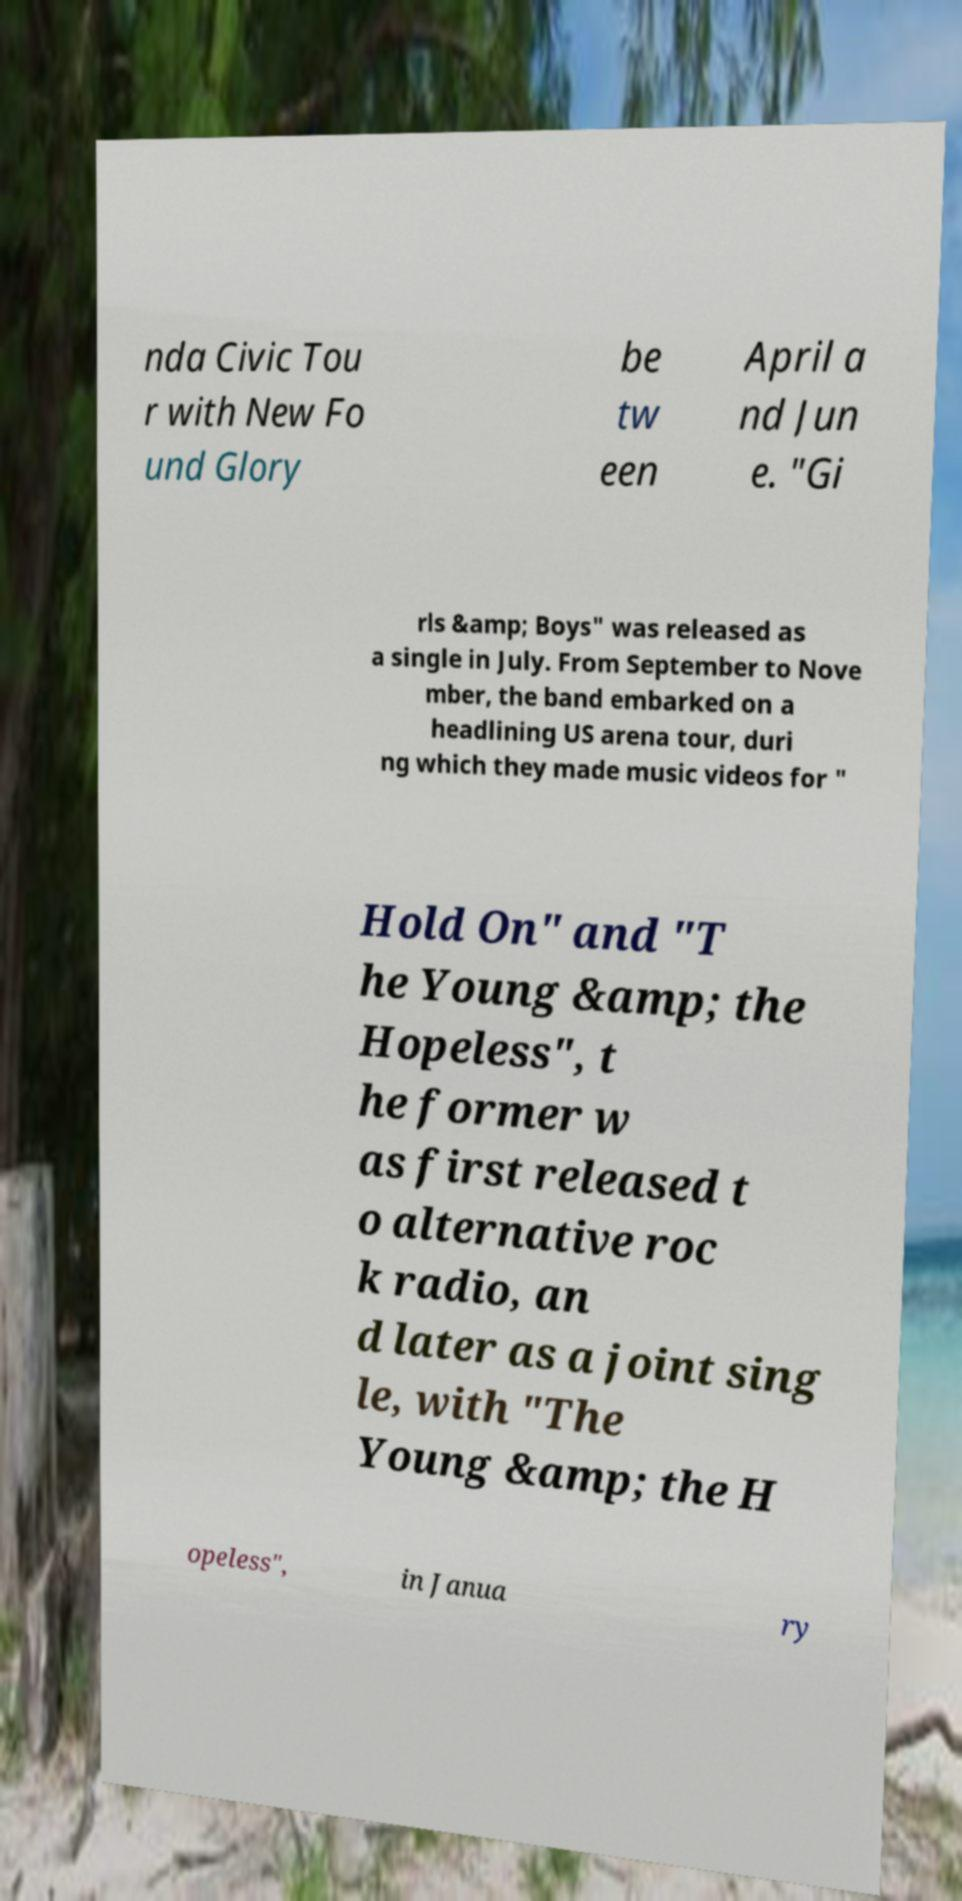I need the written content from this picture converted into text. Can you do that? nda Civic Tou r with New Fo und Glory be tw een April a nd Jun e. "Gi rls &amp; Boys" was released as a single in July. From September to Nove mber, the band embarked on a headlining US arena tour, duri ng which they made music videos for " Hold On" and "T he Young &amp; the Hopeless", t he former w as first released t o alternative roc k radio, an d later as a joint sing le, with "The Young &amp; the H opeless", in Janua ry 